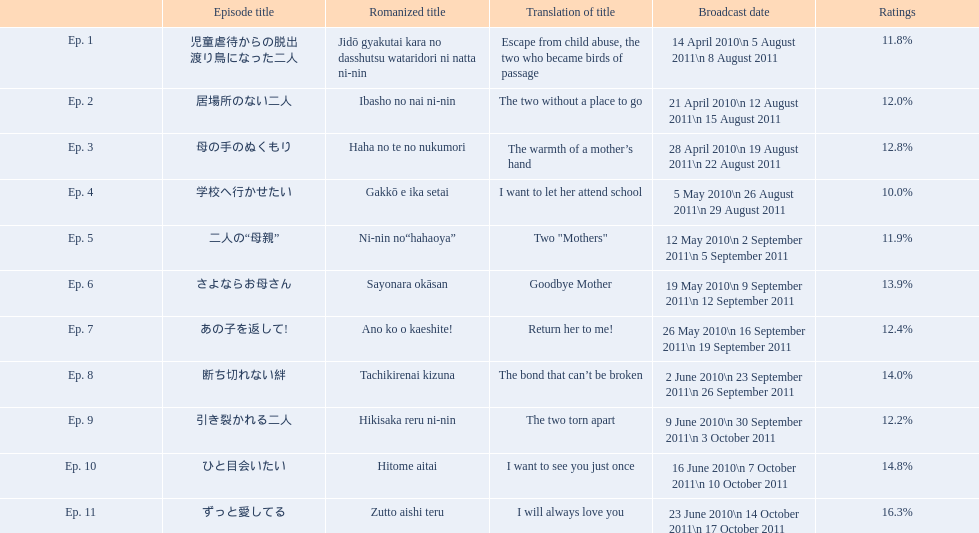Can you give me this table in json format? {'header': ['', 'Episode title', 'Romanized title', 'Translation of title', 'Broadcast date', 'Ratings'], 'rows': [['Ep. 1', '児童虐待からの脱出 渡り鳥になった二人', 'Jidō gyakutai kara no dasshutsu wataridori ni natta ni-nin', 'Escape from child abuse, the two who became birds of passage', '14 April 2010\\n 5 August 2011\\n 8 August 2011', '11.8%'], ['Ep. 2', '居場所のない二人', 'Ibasho no nai ni-nin', 'The two without a place to go', '21 April 2010\\n 12 August 2011\\n 15 August 2011', '12.0%'], ['Ep. 3', '母の手のぬくもり', 'Haha no te no nukumori', 'The warmth of a mother’s hand', '28 April 2010\\n 19 August 2011\\n 22 August 2011', '12.8%'], ['Ep. 4', '学校へ行かせたい', 'Gakkō e ika setai', 'I want to let her attend school', '5 May 2010\\n 26 August 2011\\n 29 August 2011', '10.0%'], ['Ep. 5', '二人の“母親”', 'Ni-nin no“hahaoya”', 'Two "Mothers"', '12 May 2010\\n 2 September 2011\\n 5 September 2011', '11.9%'], ['Ep. 6', 'さよならお母さん', 'Sayonara okāsan', 'Goodbye Mother', '19 May 2010\\n 9 September 2011\\n 12 September 2011', '13.9%'], ['Ep. 7', 'あの子を返して!', 'Ano ko o kaeshite!', 'Return her to me!', '26 May 2010\\n 16 September 2011\\n 19 September 2011', '12.4%'], ['Ep. 8', '断ち切れない絆', 'Tachikirenai kizuna', 'The bond that can’t be broken', '2 June 2010\\n 23 September 2011\\n 26 September 2011', '14.0%'], ['Ep. 9', '引き裂かれる二人', 'Hikisaka reru ni-nin', 'The two torn apart', '9 June 2010\\n 30 September 2011\\n 3 October 2011', '12.2%'], ['Ep. 10', 'ひと目会いたい', 'Hitome aitai', 'I want to see you just once', '16 June 2010\\n 7 October 2011\\n 10 October 2011', '14.8%'], ['Ep. 11', 'ずっと愛してる', 'Zutto aishi teru', 'I will always love you', '23 June 2010\\n 14 October 2011\\n 17 October 2011', '16.3%']]} What are the entire episodes? Ep. 1, Ep. 2, Ep. 3, Ep. 4, Ep. 5, Ep. 6, Ep. 7, Ep. 8, Ep. 9, Ep. 10, Ep. 11. Of them, which ones hold a rating of 14%? Ep. 8, Ep. 10. Out of these, which one isn't ep. 10? Ep. 8. 